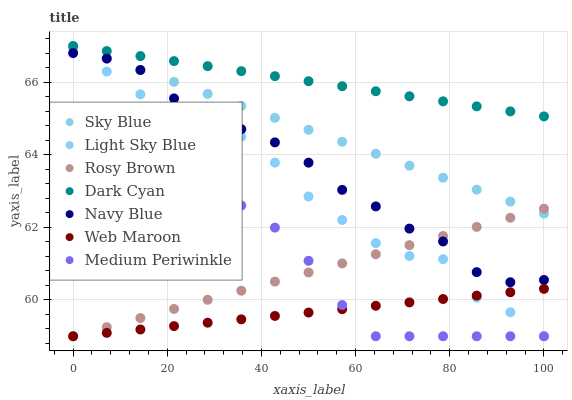Does Web Maroon have the minimum area under the curve?
Answer yes or no. Yes. Does Dark Cyan have the maximum area under the curve?
Answer yes or no. Yes. Does Navy Blue have the minimum area under the curve?
Answer yes or no. No. Does Navy Blue have the maximum area under the curve?
Answer yes or no. No. Is Sky Blue the smoothest?
Answer yes or no. Yes. Is Light Sky Blue the roughest?
Answer yes or no. Yes. Is Navy Blue the smoothest?
Answer yes or no. No. Is Navy Blue the roughest?
Answer yes or no. No. Does Medium Periwinkle have the lowest value?
Answer yes or no. Yes. Does Navy Blue have the lowest value?
Answer yes or no. No. Does Sky Blue have the highest value?
Answer yes or no. Yes. Does Navy Blue have the highest value?
Answer yes or no. No. Is Web Maroon less than Sky Blue?
Answer yes or no. Yes. Is Dark Cyan greater than Light Sky Blue?
Answer yes or no. Yes. Does Medium Periwinkle intersect Web Maroon?
Answer yes or no. Yes. Is Medium Periwinkle less than Web Maroon?
Answer yes or no. No. Is Medium Periwinkle greater than Web Maroon?
Answer yes or no. No. Does Web Maroon intersect Sky Blue?
Answer yes or no. No. 